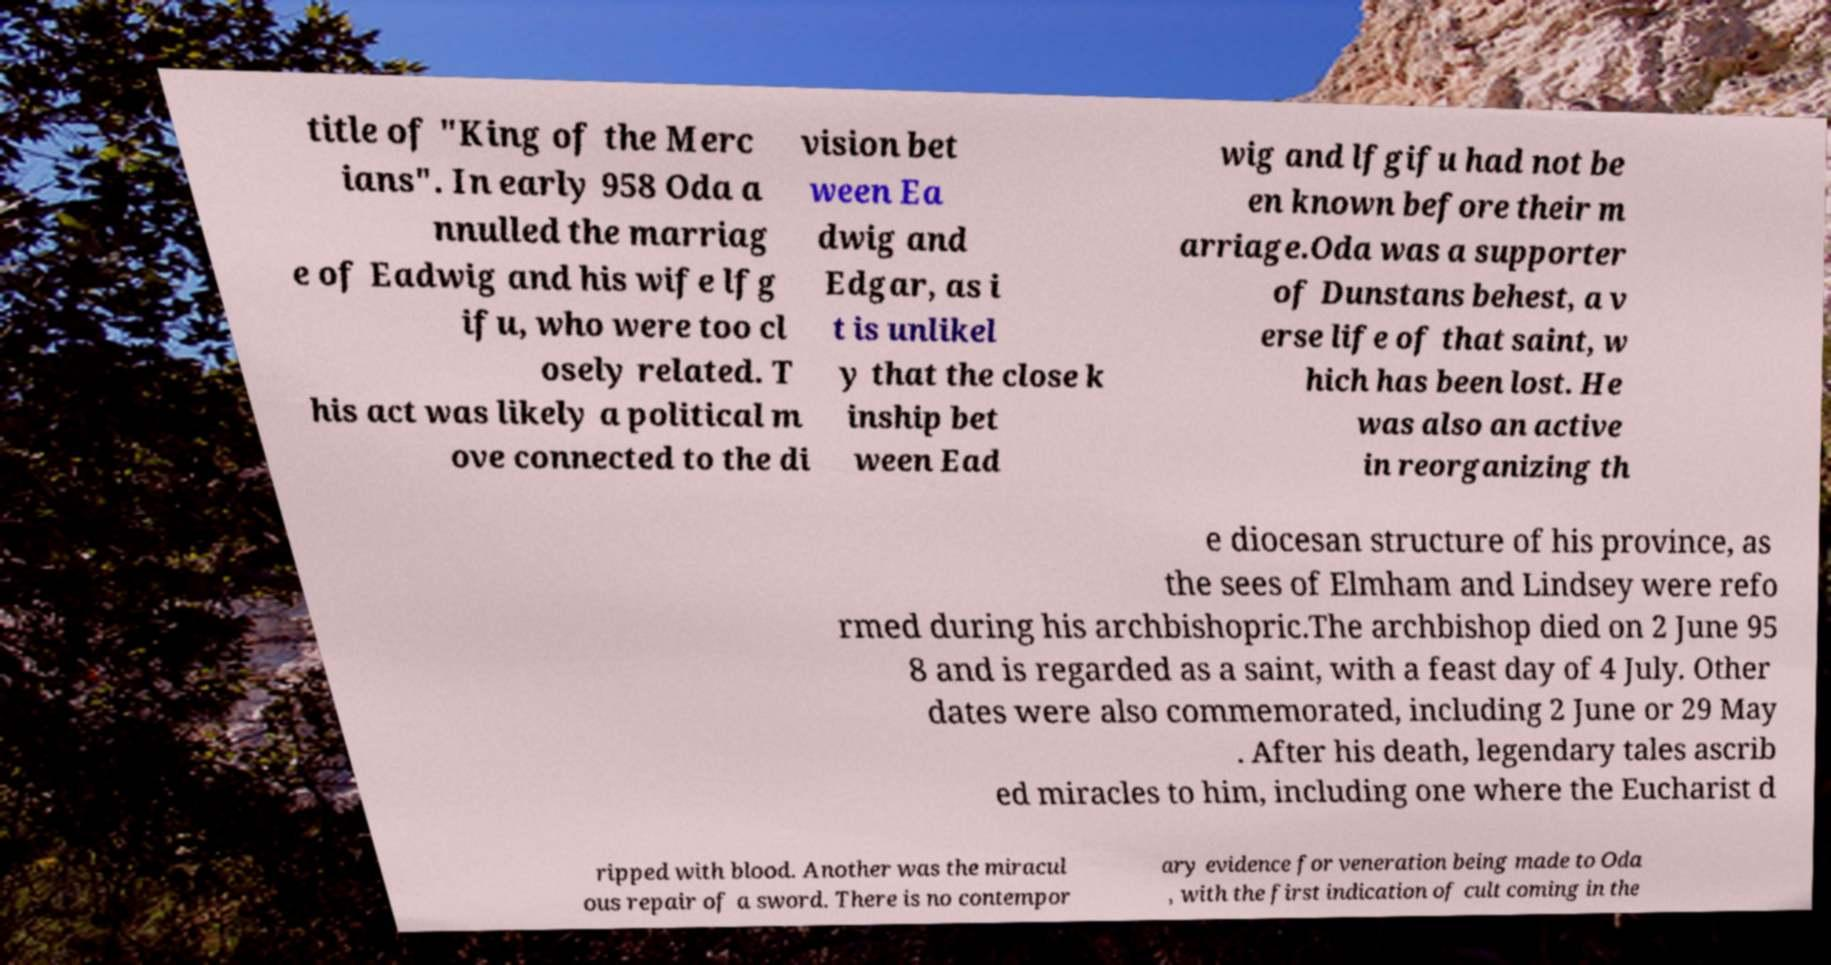For documentation purposes, I need the text within this image transcribed. Could you provide that? title of "King of the Merc ians". In early 958 Oda a nnulled the marriag e of Eadwig and his wife lfg ifu, who were too cl osely related. T his act was likely a political m ove connected to the di vision bet ween Ea dwig and Edgar, as i t is unlikel y that the close k inship bet ween Ead wig and lfgifu had not be en known before their m arriage.Oda was a supporter of Dunstans behest, a v erse life of that saint, w hich has been lost. He was also an active in reorganizing th e diocesan structure of his province, as the sees of Elmham and Lindsey were refo rmed during his archbishopric.The archbishop died on 2 June 95 8 and is regarded as a saint, with a feast day of 4 July. Other dates were also commemorated, including 2 June or 29 May . After his death, legendary tales ascrib ed miracles to him, including one where the Eucharist d ripped with blood. Another was the miracul ous repair of a sword. There is no contempor ary evidence for veneration being made to Oda , with the first indication of cult coming in the 